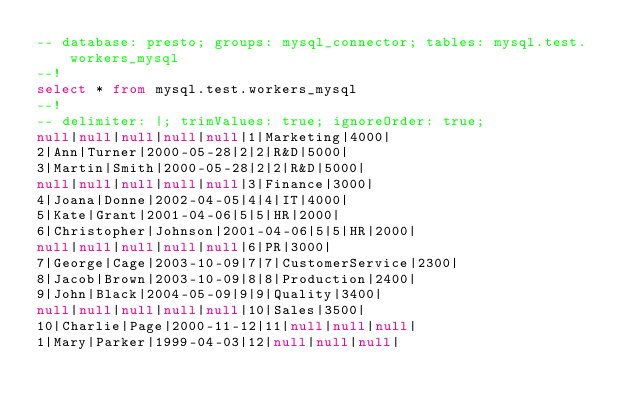<code> <loc_0><loc_0><loc_500><loc_500><_SQL_>-- database: presto; groups: mysql_connector; tables: mysql.test.workers_mysql
--!
select * from mysql.test.workers_mysql
--!
-- delimiter: |; trimValues: true; ignoreOrder: true;
null|null|null|null|null|1|Marketing|4000|
2|Ann|Turner|2000-05-28|2|2|R&D|5000|
3|Martin|Smith|2000-05-28|2|2|R&D|5000|
null|null|null|null|null|3|Finance|3000|
4|Joana|Donne|2002-04-05|4|4|IT|4000|
5|Kate|Grant|2001-04-06|5|5|HR|2000|
6|Christopher|Johnson|2001-04-06|5|5|HR|2000|
null|null|null|null|null|6|PR|3000|
7|George|Cage|2003-10-09|7|7|CustomerService|2300|
8|Jacob|Brown|2003-10-09|8|8|Production|2400|
9|John|Black|2004-05-09|9|9|Quality|3400|
null|null|null|null|null|10|Sales|3500|
10|Charlie|Page|2000-11-12|11|null|null|null|
1|Mary|Parker|1999-04-03|12|null|null|null|
</code> 